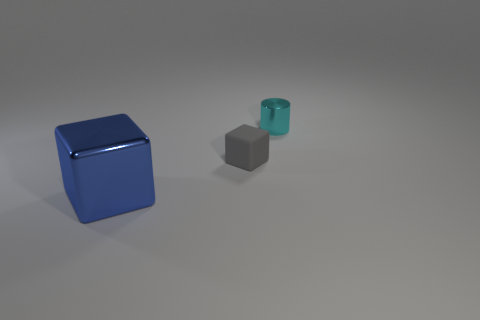Are the cube right of the large blue object and the object that is left of the gray rubber thing made of the same material?
Offer a very short reply. No. Is the number of small gray matte things greater than the number of tiny purple matte things?
Keep it short and to the point. Yes. The metallic thing that is on the right side of the small thing that is in front of the shiny thing that is on the right side of the metal block is what color?
Your answer should be very brief. Cyan. Do the metal thing behind the blue shiny cube and the block that is behind the big metallic block have the same color?
Keep it short and to the point. No. How many small shiny cylinders are behind the thing behind the gray rubber block?
Offer a very short reply. 0. Is there a cyan rubber thing?
Offer a terse response. No. Are there fewer big gray things than large blue cubes?
Ensure brevity in your answer.  Yes. What shape is the small object on the left side of the shiny thing behind the blue metallic cube?
Give a very brief answer. Cube. There is a small cyan shiny object; are there any small cyan metal things in front of it?
Make the answer very short. No. The matte thing that is the same size as the cylinder is what color?
Your response must be concise. Gray. 